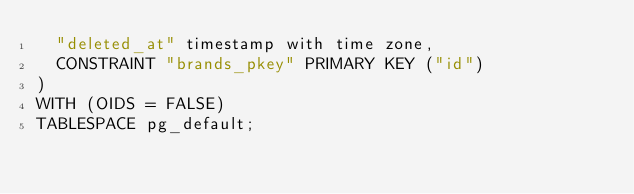Convert code to text. <code><loc_0><loc_0><loc_500><loc_500><_SQL_>	"deleted_at" timestamp with time zone,
	CONSTRAINT "brands_pkey" PRIMARY KEY ("id")
)
WITH (OIDS = FALSE)
TABLESPACE pg_default;
</code> 